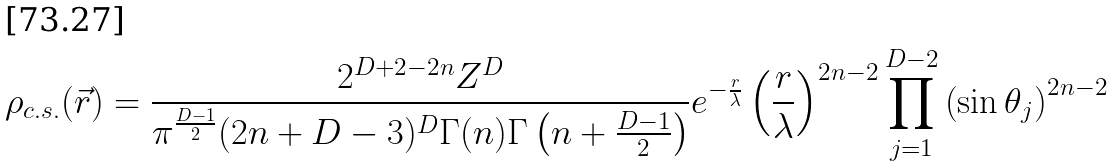<formula> <loc_0><loc_0><loc_500><loc_500>\rho _ { c . s . } ( \vec { r } ) = \frac { 2 ^ { D + 2 - 2 n } Z ^ { D } } { \pi ^ { \frac { D - 1 } { 2 } } ( 2 n + D - 3 ) ^ { D } \Gamma ( n ) \Gamma \left ( n + \frac { D - 1 } { 2 } \right ) } e ^ { - \frac { r } { \lambda } } \left ( \frac { r } { \lambda } \right ) ^ { 2 n - 2 } \prod ^ { D - 2 } _ { j = 1 } \left ( \sin \theta _ { j } \right ) ^ { 2 n - 2 }</formula> 